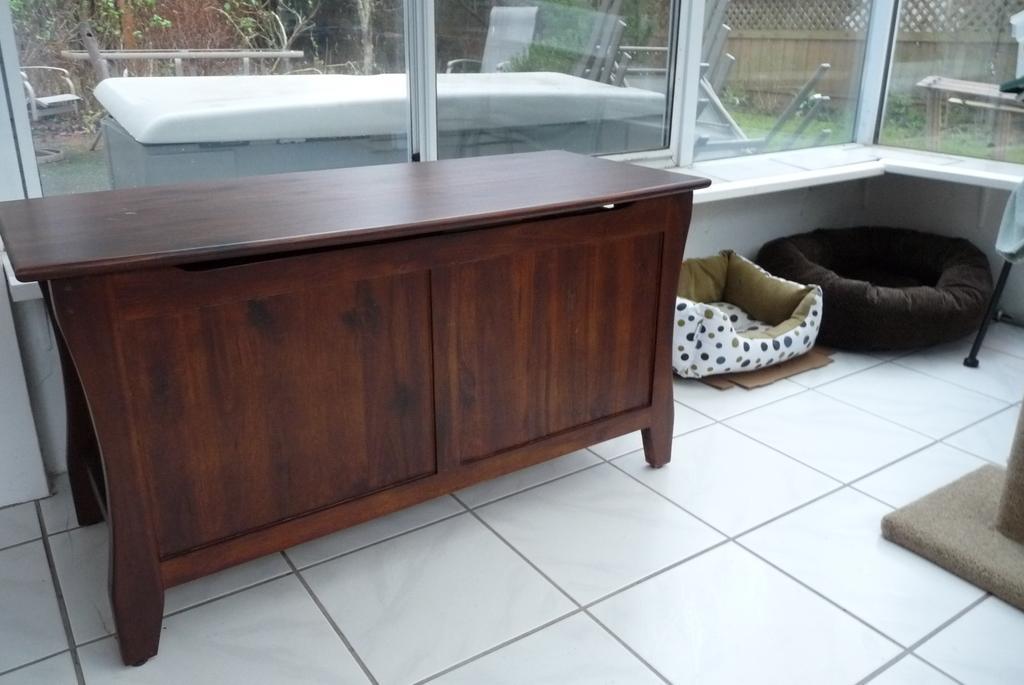Could you give a brief overview of what you see in this image? This is the picture taken in a room, the floor is covered with white tiles on the floor there are two dog beds and a wooden table and a mat. Behind the table there are glass windows through which we can see the outside view, fencing, trees and a table. 